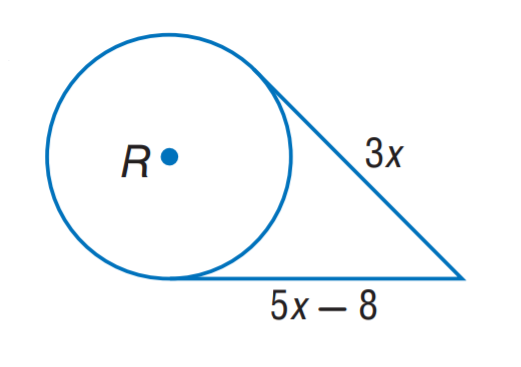Answer the mathemtical geometry problem and directly provide the correct option letter.
Question: The segment is tangent to the circle. Find x.
Choices: A: 3 B: 4 C: 5 D: 8 B 